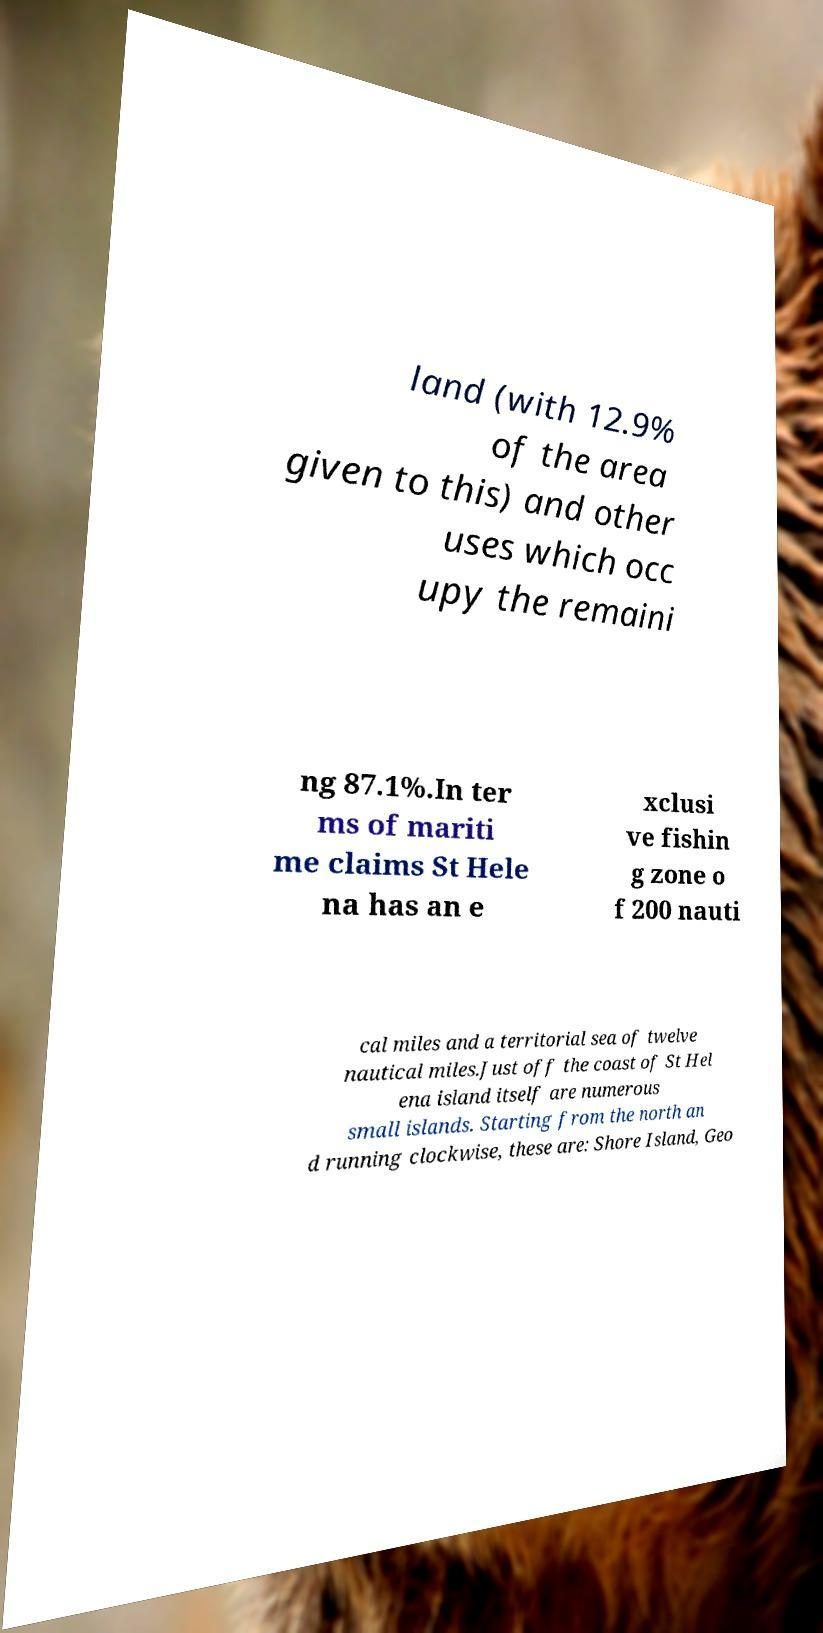Please identify and transcribe the text found in this image. land (with 12.9% of the area given to this) and other uses which occ upy the remaini ng 87.1%.In ter ms of mariti me claims St Hele na has an e xclusi ve fishin g zone o f 200 nauti cal miles and a territorial sea of twelve nautical miles.Just off the coast of St Hel ena island itself are numerous small islands. Starting from the north an d running clockwise, these are: Shore Island, Geo 